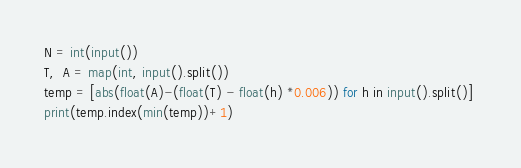Convert code to text. <code><loc_0><loc_0><loc_500><loc_500><_Python_>N = int(input())
T,  A = map(int, input().split())
temp = [abs(float(A)-(float(T) - float(h) *0.006)) for h in input().split()] 
print(temp.index(min(temp))+1)</code> 